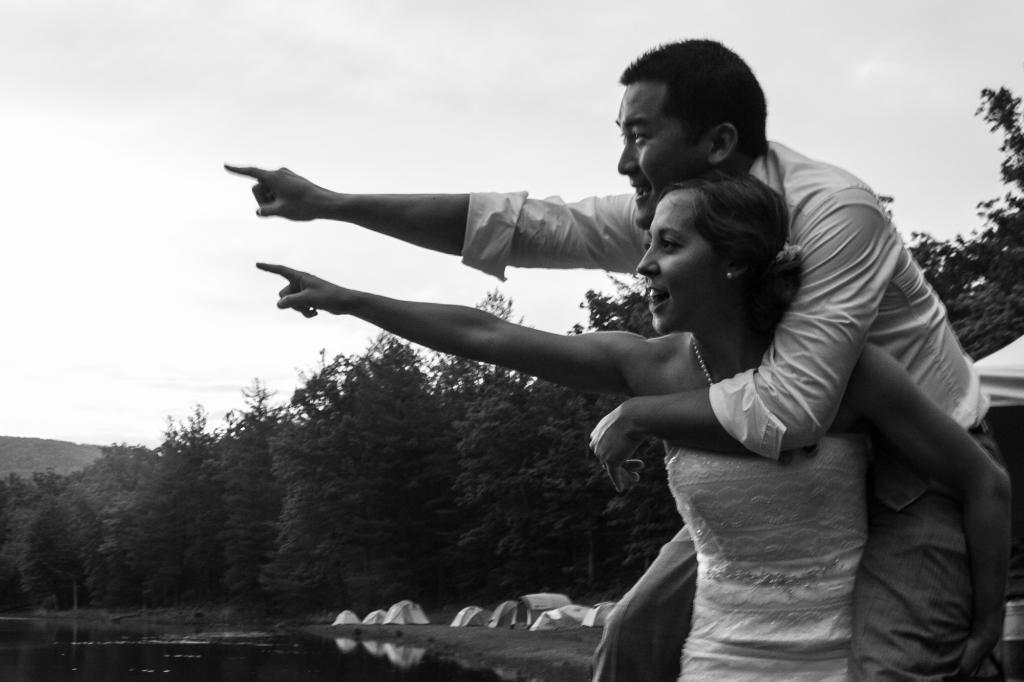Could you give a brief overview of what you see in this image? Here we can see a woman and a man. They are pointing fingers towards the left side of a picture. Here we can see water, tents, and trees. In the background there is sky. 